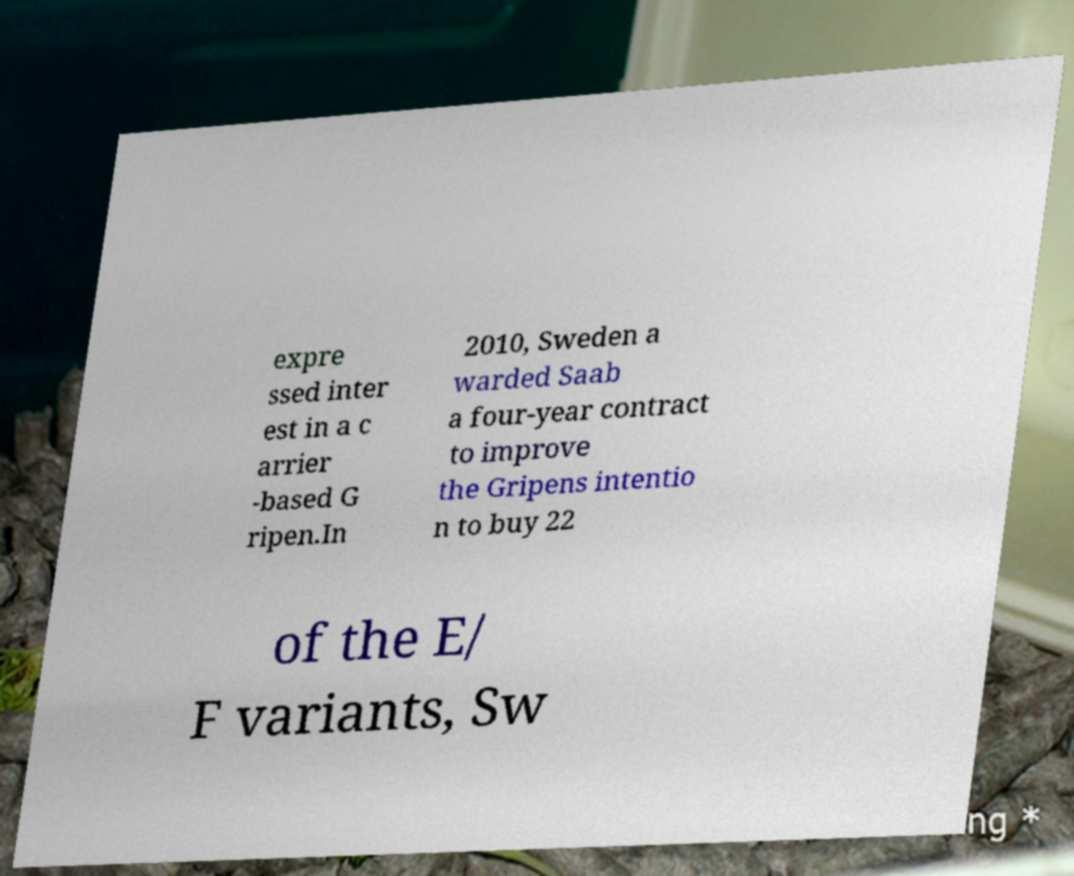For documentation purposes, I need the text within this image transcribed. Could you provide that? expre ssed inter est in a c arrier -based G ripen.In 2010, Sweden a warded Saab a four-year contract to improve the Gripens intentio n to buy 22 of the E/ F variants, Sw 